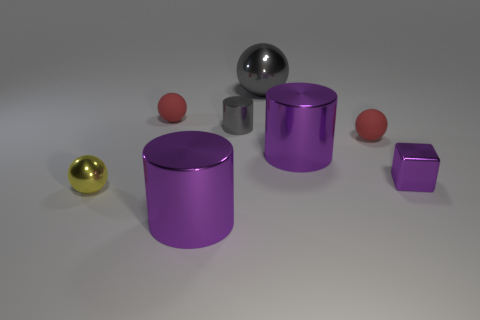How many purple cylinders must be subtracted to get 1 purple cylinders? 1 Subtract all gray metal cylinders. How many cylinders are left? 2 Subtract all yellow balls. How many balls are left? 3 Subtract all purple shiny things. Subtract all big shiny cylinders. How many objects are left? 3 Add 6 gray cylinders. How many gray cylinders are left? 7 Add 3 tiny yellow cylinders. How many tiny yellow cylinders exist? 3 Add 1 small balls. How many objects exist? 9 Subtract 0 blue cubes. How many objects are left? 8 Subtract all cubes. How many objects are left? 7 Subtract 1 cylinders. How many cylinders are left? 2 